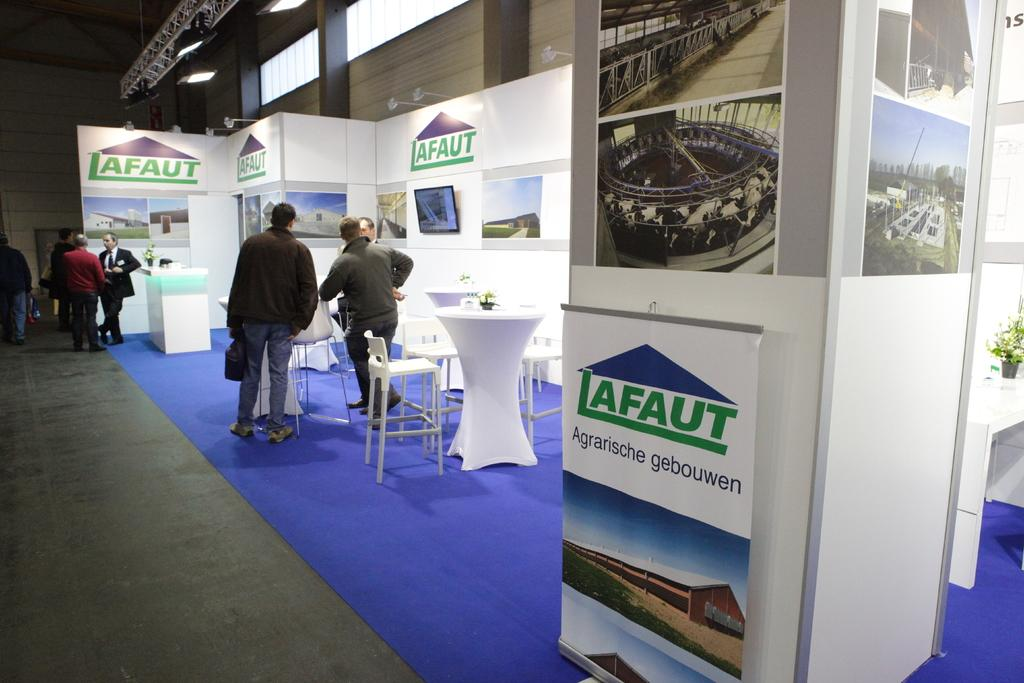<image>
Write a terse but informative summary of the picture. some people at an event with the name Lafaut  in the title. 